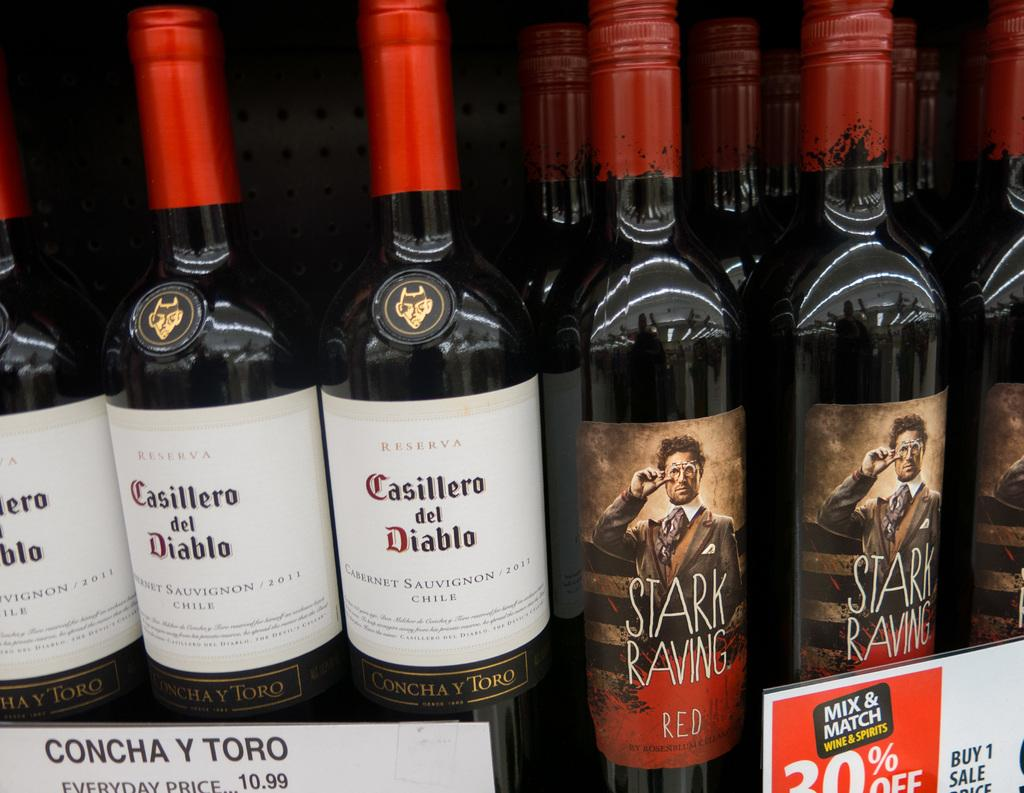<image>
Share a concise interpretation of the image provided. A display of wines with two different brands that are Casillero del diablo and Starving Raving 